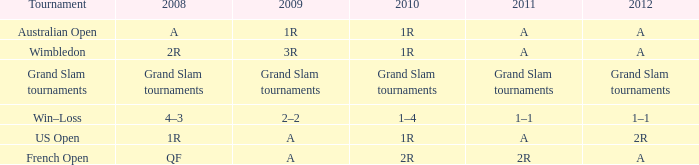Name the 2011 when 2010 is 2r 2R. 